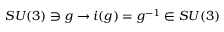Convert formula to latex. <formula><loc_0><loc_0><loc_500><loc_500>S U ( 3 ) \ni g \rightarrow i ( g ) = g ^ { - 1 } \in S U ( 3 )</formula> 